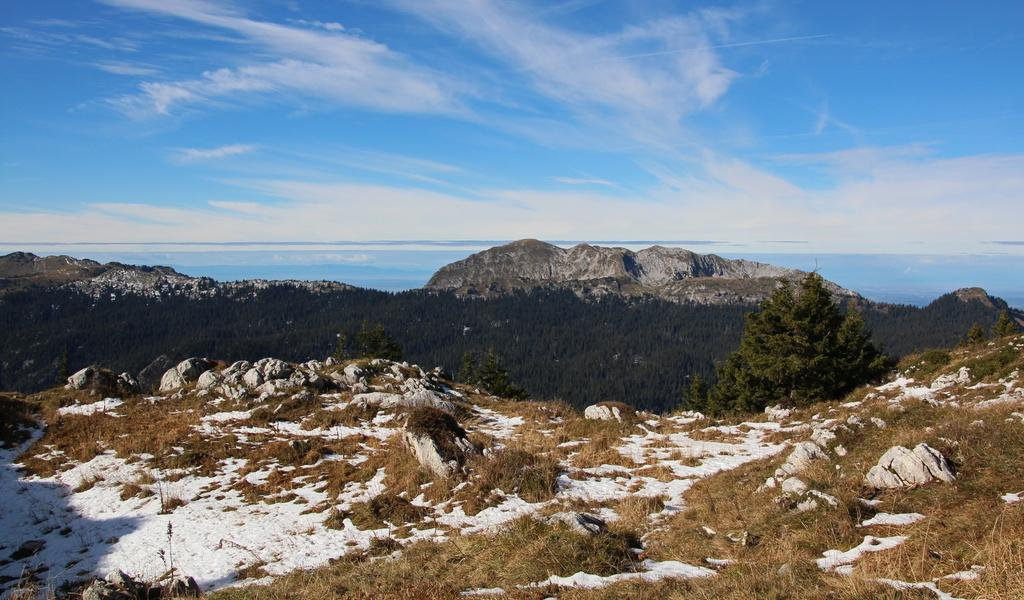What type of weather is depicted in the image? There is snow in the image, indicating cold weather. What type of vegetation can be seen in the image? Dry grass is present in the image. What type of landscape feature is visible in the image? There are trees in the image. What type of terrain can be seen in the image? Hills are visible in the image. What is visible in the sky in the image? The sky is visible in the image, and clouds are present. What type of sidewalk can be seen in the image? There is no sidewalk present in the image; it is set in a natural landscape with snow, dry grass, trees, hills, and a cloudy sky. 